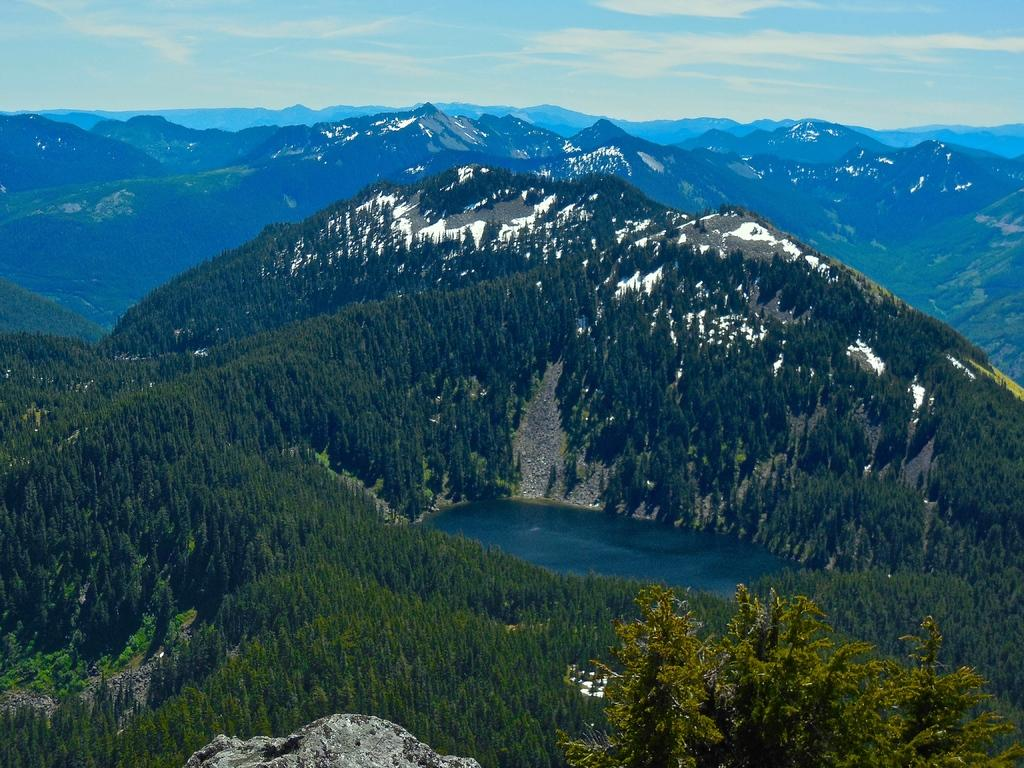What type of natural landform can be seen in the image? There are mountains in the image. What other natural elements are present in the image? There are trees and water in the image. What is the condition of the sky in the image? The sky is visible in the image, and there are clouds present. How many bricks are used to construct the mountains in the image? The mountains in the image are natural landforms and not constructed with bricks. 